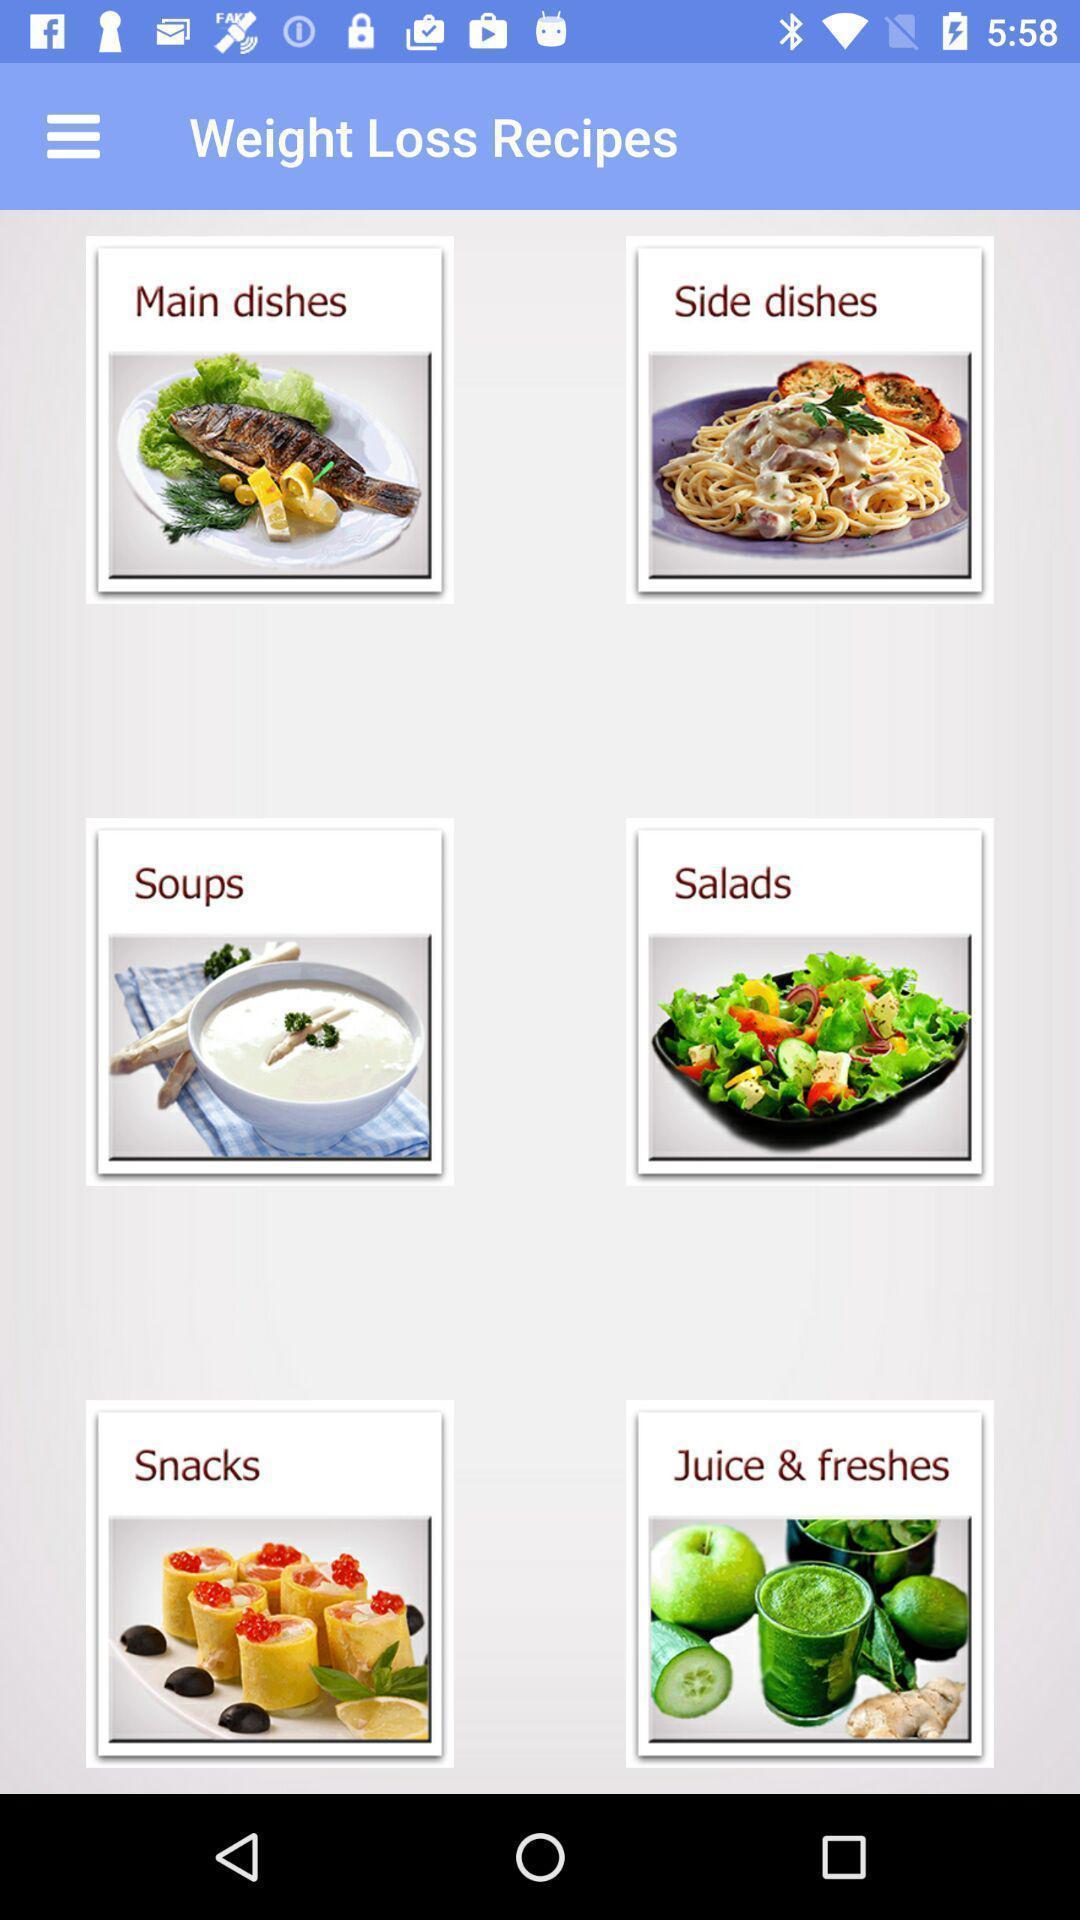What can you discern from this picture? Page showing different recipes available. 